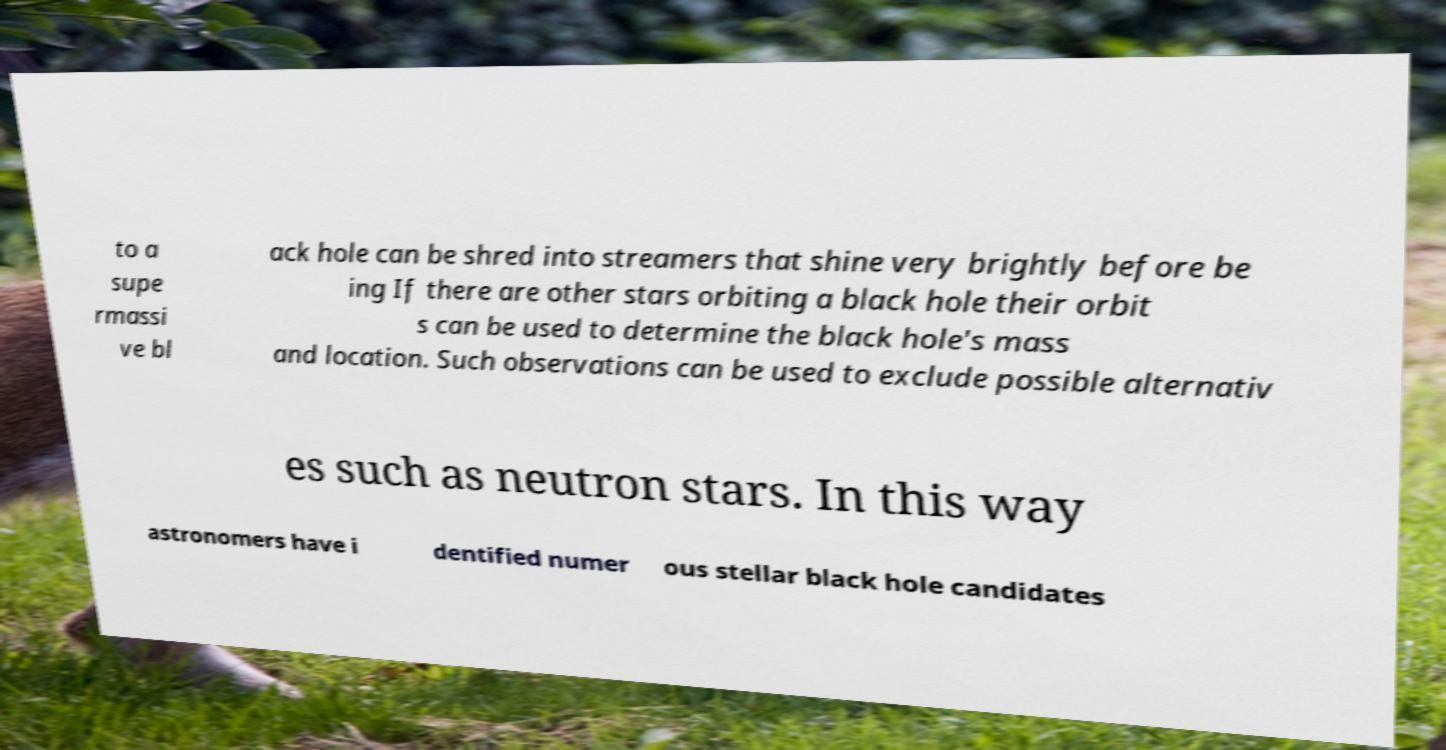I need the written content from this picture converted into text. Can you do that? to a supe rmassi ve bl ack hole can be shred into streamers that shine very brightly before be ing If there are other stars orbiting a black hole their orbit s can be used to determine the black hole's mass and location. Such observations can be used to exclude possible alternativ es such as neutron stars. In this way astronomers have i dentified numer ous stellar black hole candidates 